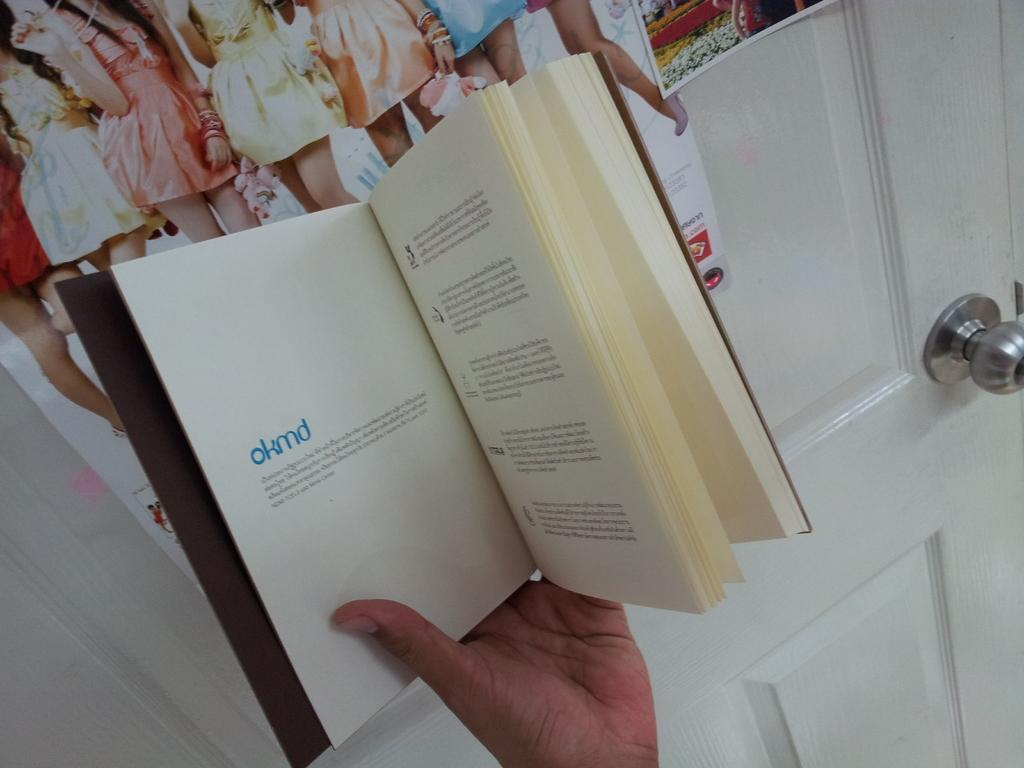<image>
Relay a brief, clear account of the picture shown. The chapter on OKMD stands for Office of Knowledge Management and Development. 